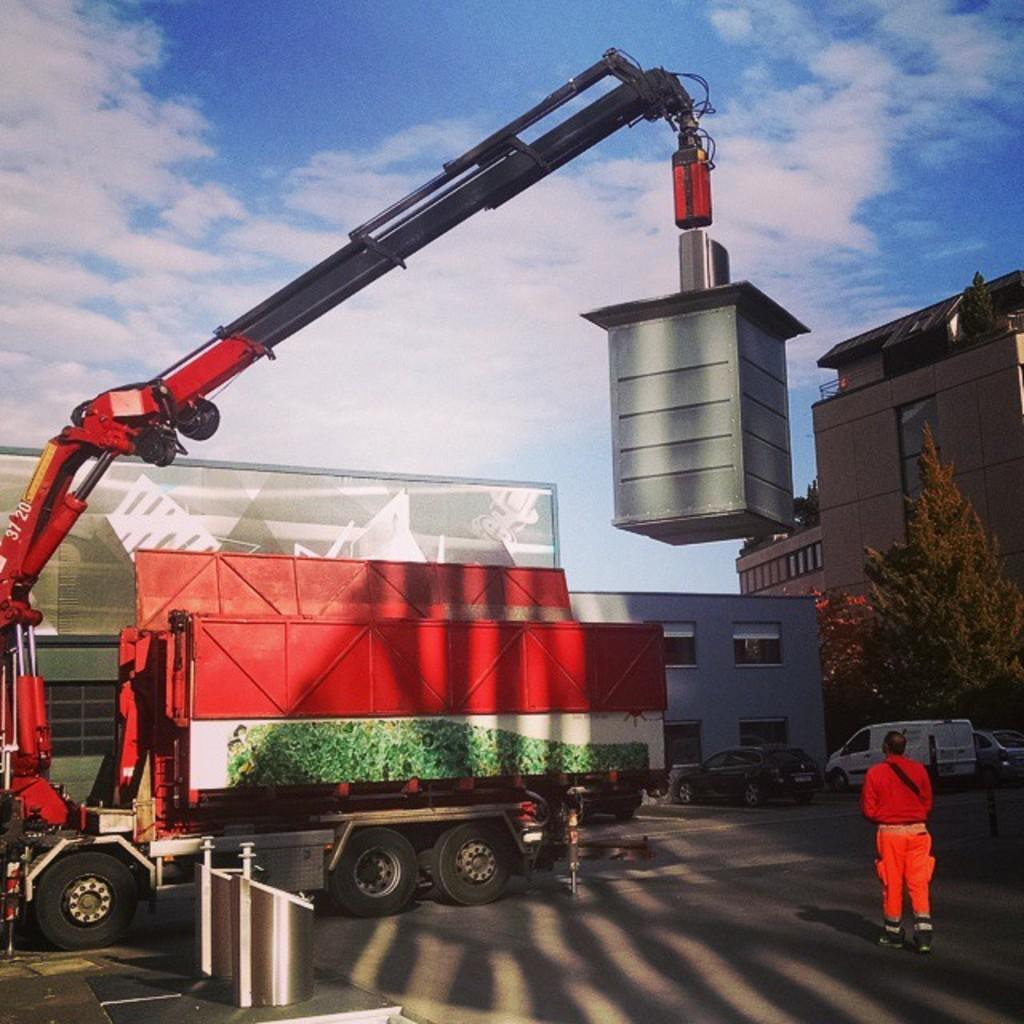<image>
Offer a succinct explanation of the picture presented. a crane with a label on the neck that says '37 and 20' on it 